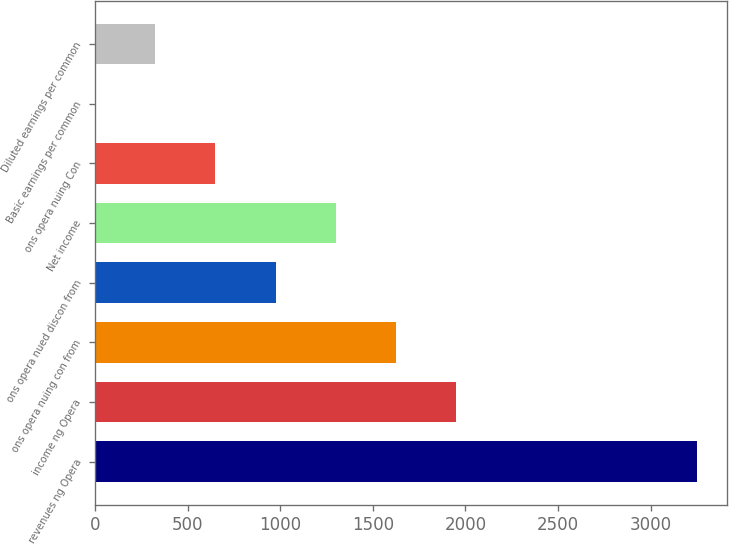<chart> <loc_0><loc_0><loc_500><loc_500><bar_chart><fcel>revenues ng Opera<fcel>income ng Opera<fcel>ons opera nuing con from<fcel>ons opera nued discon from<fcel>Net income<fcel>ons opera nuing Con<fcel>Basic earnings per common<fcel>Diluted earnings per common<nl><fcel>3248<fcel>1949.12<fcel>1624.39<fcel>974.93<fcel>1299.66<fcel>650.2<fcel>0.74<fcel>325.47<nl></chart> 